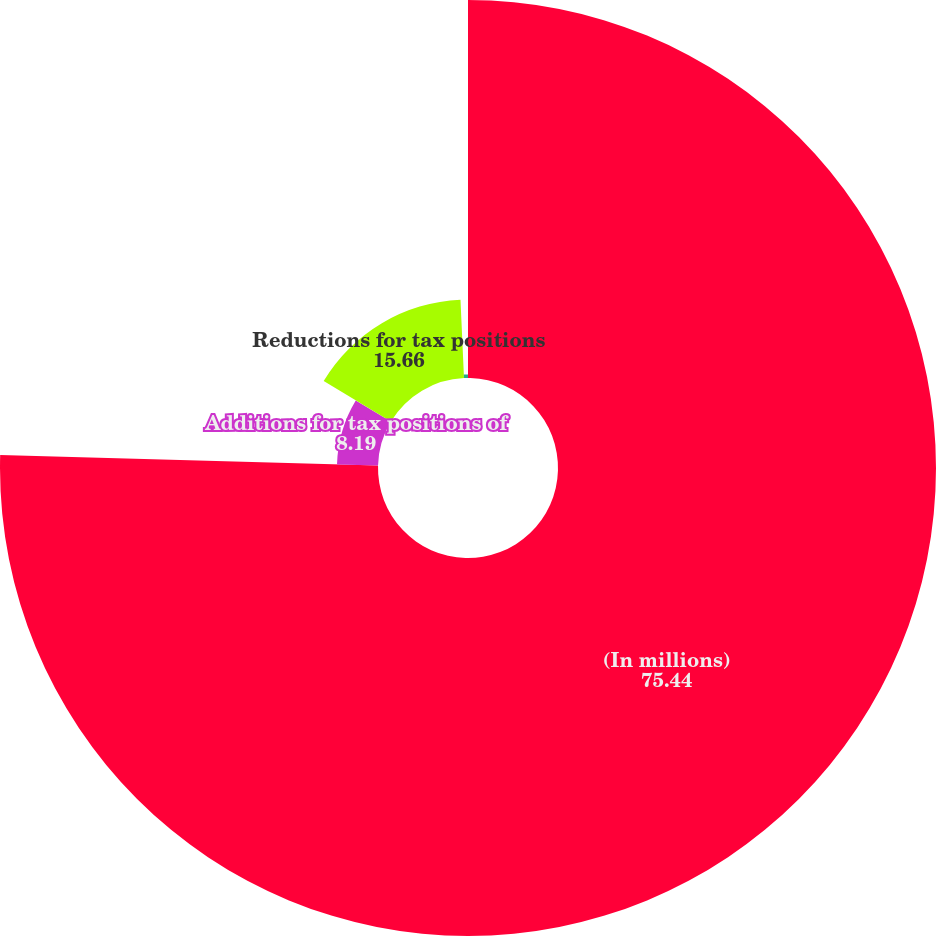<chart> <loc_0><loc_0><loc_500><loc_500><pie_chart><fcel>(In millions)<fcel>Additions for tax positions of<fcel>Reductions for tax positions<fcel>Settlements<nl><fcel>75.44%<fcel>8.19%<fcel>15.66%<fcel>0.71%<nl></chart> 